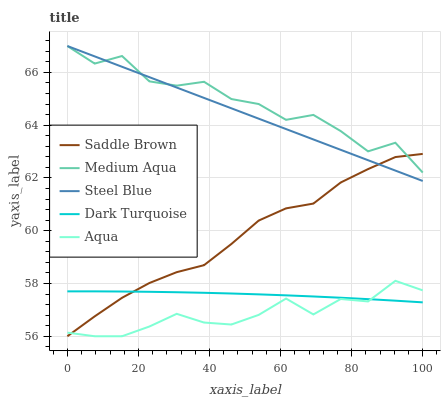Does Aqua have the minimum area under the curve?
Answer yes or no. Yes. Does Medium Aqua have the maximum area under the curve?
Answer yes or no. Yes. Does Dark Turquoise have the minimum area under the curve?
Answer yes or no. No. Does Dark Turquoise have the maximum area under the curve?
Answer yes or no. No. Is Steel Blue the smoothest?
Answer yes or no. Yes. Is Medium Aqua the roughest?
Answer yes or no. Yes. Is Dark Turquoise the smoothest?
Answer yes or no. No. Is Dark Turquoise the roughest?
Answer yes or no. No. Does Dark Turquoise have the lowest value?
Answer yes or no. No. Does Dark Turquoise have the highest value?
Answer yes or no. No. Is Aqua less than Steel Blue?
Answer yes or no. Yes. Is Steel Blue greater than Aqua?
Answer yes or no. Yes. Does Aqua intersect Steel Blue?
Answer yes or no. No. 